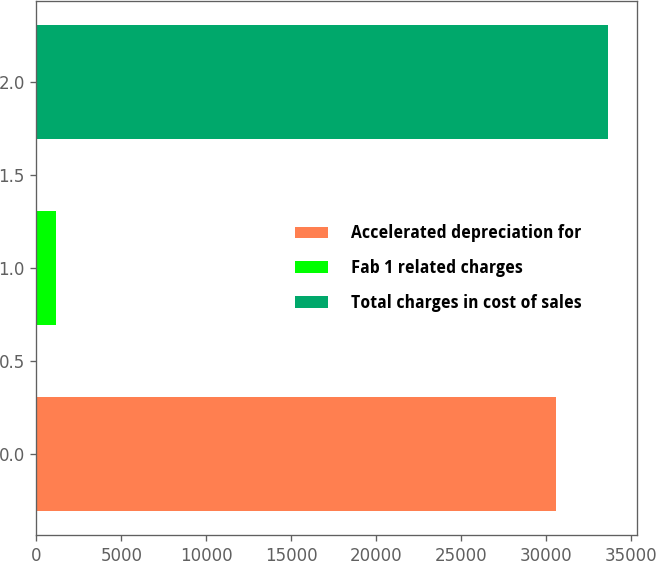Convert chart to OTSL. <chart><loc_0><loc_0><loc_500><loc_500><bar_chart><fcel>Accelerated depreciation for<fcel>Fab 1 related charges<fcel>Total charges in cost of sales<nl><fcel>30608<fcel>1147<fcel>33668.8<nl></chart> 